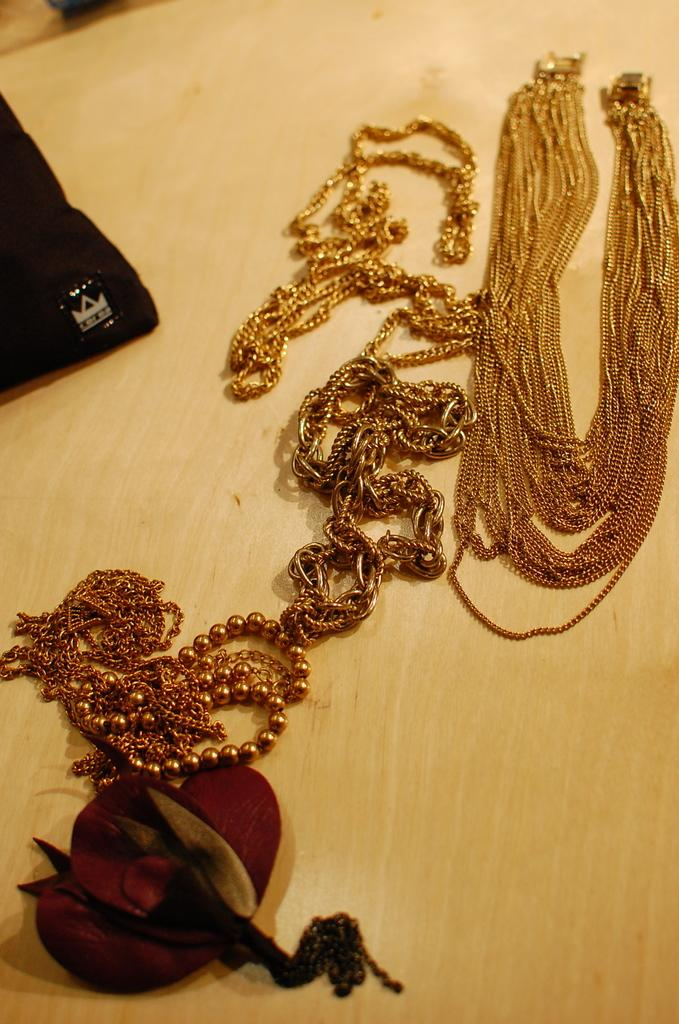What type of furniture is present in the image? There is a table in the image. What items can be seen on the table? There are jewelry items on the table. What type of surprise is hidden under the table in the image? There is no indication of a surprise hidden under the table in the image. Can you see any worms crawling on the jewelry items in the image? There are no worms present in the image. 